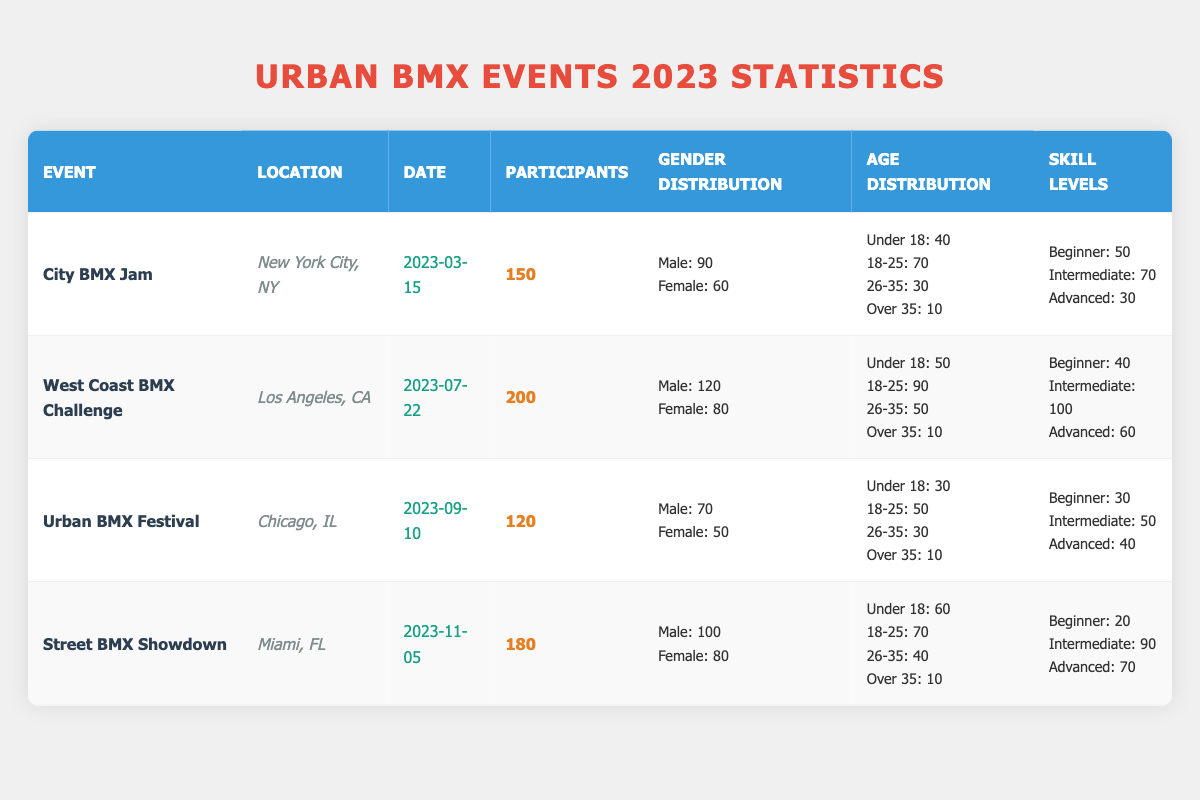What is the total number of participants across all events? To find the total number of participants, we need to sum the participants from each event: 150 (City BMX Jam) + 200 (West Coast BMX Challenge) + 120 (Urban BMX Festival) + 180 (Street BMX Showdown) = 650.
Answer: 650 Which event had the highest number of male participants? Reviewing the gender distribution, the West Coast BMX Challenge had 120 male participants, which is higher than the other events: 90 (City BMX Jam), 70 (Urban BMX Festival), and 100 (Street BMX Showdown).
Answer: West Coast BMX Challenge What percentage of participants in the Urban BMX Festival were female? The Urban BMX Festival had 120 participants, and 50 of them were female. To find the percentage, use the formula: (female participants / total participants) * 100 = (50 / 120) * 100 = 41.67%.
Answer: 41.67% How many participants were 18 to 25 years old in the Street BMX Showdown? From the age distribution for the Street BMX Showdown, it shows that there were 70 participants who were 18 to 25 years old.
Answer: 70 Is there a higher number of intermediate skill level participants than beginner skill level participants in the City BMX Jam? For the City BMX Jam, there were 70 intermediate participants and 50 beginner participants. Since 70 is more than 50, the answer is yes.
Answer: Yes What is the average number of participants per event? There are four events: City BMX Jam (150), West Coast BMX Challenge (200), Urban BMX Festival (120), and Street BMX Showdown (180). The average is calculated by summing the total participants (650) and dividing by the number of events (4): 650 / 4 = 162.5.
Answer: 162.5 What age group had the least number of participants in the West Coast BMX Challenge? From the age distribution, the category with the lowest number of participants is Over 35, with 10 participants.
Answer: Over 35 How many more female participants were there in the West Coast BMX Challenge compared to the Urban BMX Festival? The West Coast BMX Challenge has 80 female participants, while the Urban BMX Festival has 50. The difference is calculated as 80 - 50 = 30.
Answer: 30 